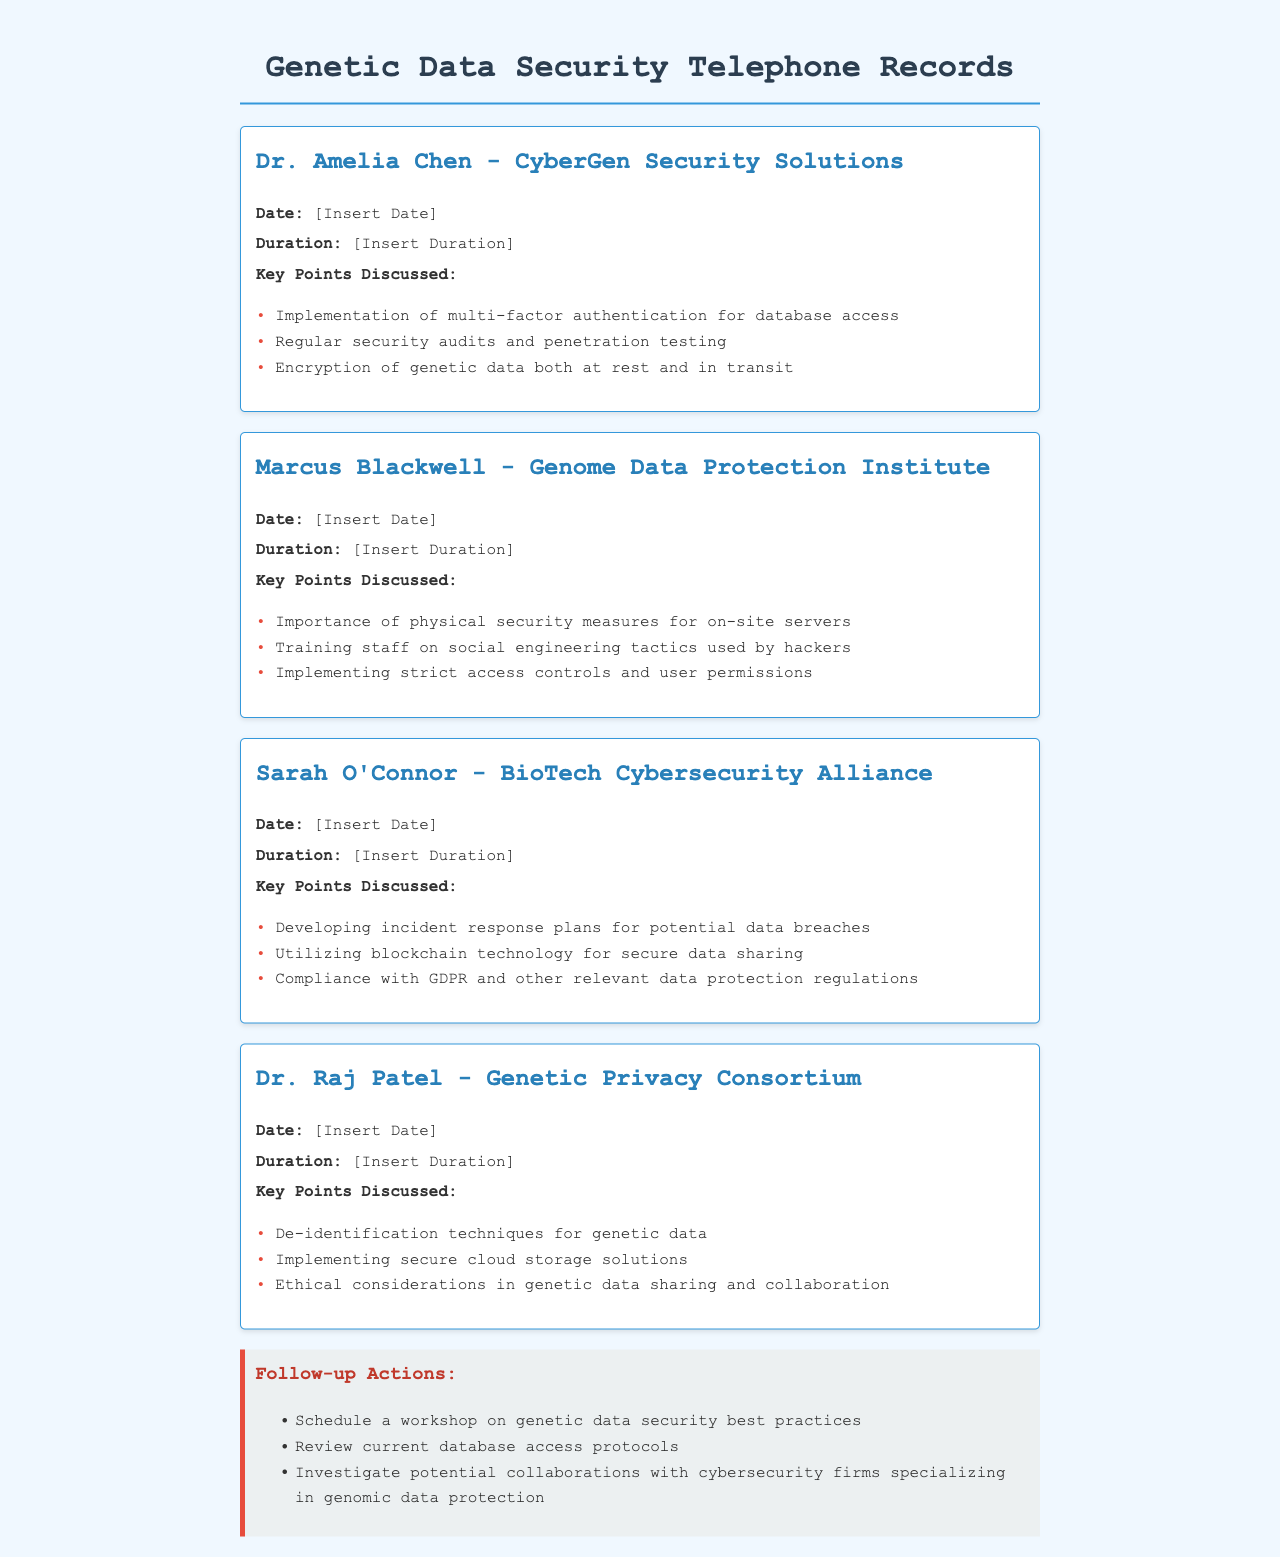What is the name of the first expert mentioned? The first expert discussed in the document is Dr. Amelia Chen from CyberGen Security Solutions.
Answer: Dr. Amelia Chen What is one of the key points discussed by Marcus Blackwell? One key point he mentioned is the importance of physical security measures for on-site servers.
Answer: Importance of physical security measures for on-site servers What date was the conversation with Sarah O'Connor held? The document does not specify any dates for the conversations.
Answer: [Insert Date] What is a recommended follow-up action listed in the document? One follow-up action is to schedule a workshop on genetic data security best practices.
Answer: Schedule a workshop on genetic data security best practices Which technology was suggested by Sarah O'Connor for secure data sharing? Sarah O'Connor recommended utilizing blockchain technology for secure data sharing.
Answer: Blockchain technology What is emphasized as a key consideration by Dr. Raj Patel? Dr. Raj Patel emphasizes ethical considerations in genetic data sharing and collaboration.
Answer: Ethical considerations What type of security audits are mentioned in Dr. Amelia Chen's discussion? Dr. Amelia Chen mentioned regular security audits and penetration testing.
Answer: Regular security audits and penetration testing What is the duration of the conversations? The document does not specify any durations for the conversations.
Answer: [Insert Duration] 